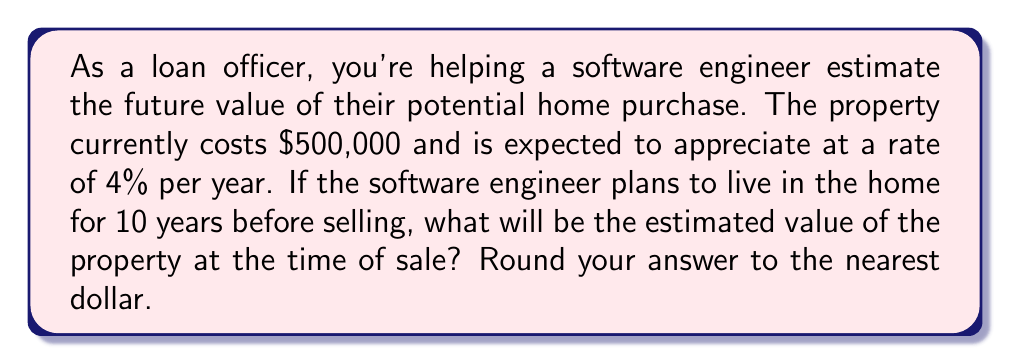Teach me how to tackle this problem. To solve this problem, we need to use the compound interest formula, as property appreciation works similarly to compound interest. The formula is:

$$A = P(1 + r)^n$$

Where:
$A$ = Final amount
$P$ = Principal (initial investment)
$r$ = Annual rate of appreciation (as a decimal)
$n$ = Number of years

Given:
$P = \$500,000$
$r = 0.04$ (4% expressed as a decimal)
$n = 10$ years

Let's substitute these values into the formula:

$$A = 500,000(1 + 0.04)^{10}$$

Now, let's calculate step by step:

1) First, calculate $(1 + 0.04)^{10}$:
   $$(1.04)^{10} = 1.4802443369$$

2) Multiply this by the initial value:
   $$500,000 \times 1.4802443369 = 740,122.1684$$

3) Round to the nearest dollar:
   $$740,122$$

Therefore, the estimated value of the property after 10 years would be $740,122.
Answer: $740,122 